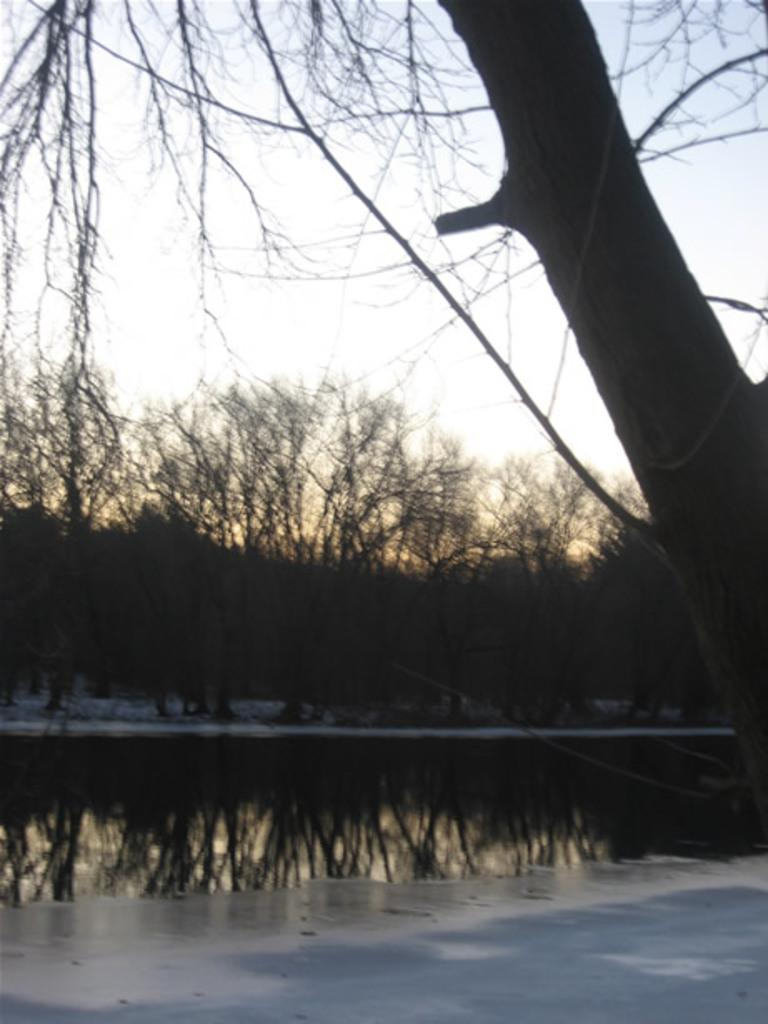What is one of the natural elements present in the image? There is water in the image. What is another natural element present in the image? There is snow in the image. What type of vegetation can be seen in the image? There are trees in the image. What is visible in the background of the image? The sky is visible in the background of the image. What type of meat is being served on a fork in the image? There is no fork or meat present in the image. How many chickens can be seen in the image? There are no chickens present in the image. 